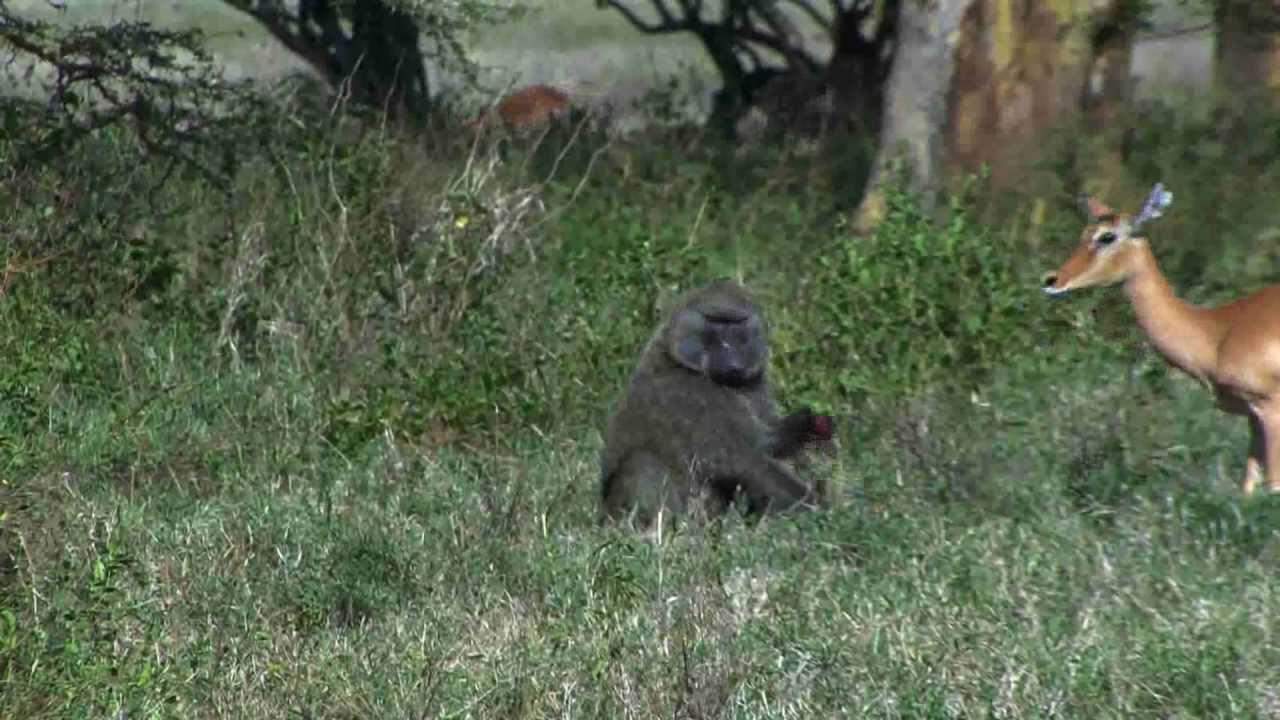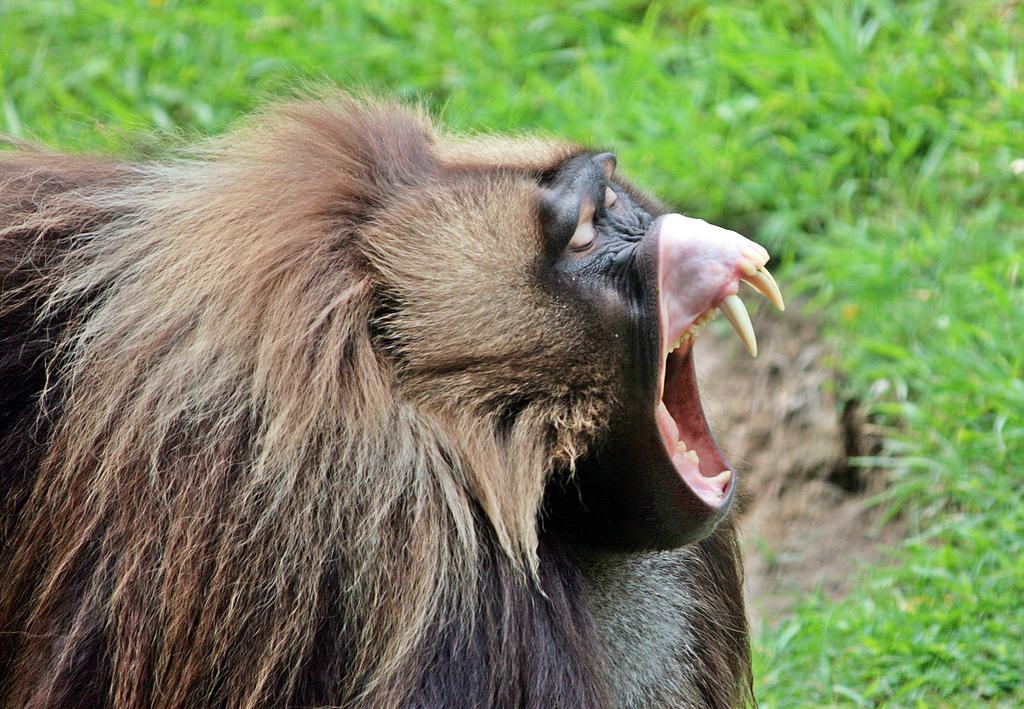The first image is the image on the left, the second image is the image on the right. Evaluate the accuracy of this statement regarding the images: "At least one monkey has its mouth wide open with sharp teeth visible.". Is it true? Answer yes or no. Yes. The first image is the image on the left, the second image is the image on the right. Analyze the images presented: Is the assertion "An image show a right-facing monkey with wide-opened mouth baring its fangs." valid? Answer yes or no. Yes. 